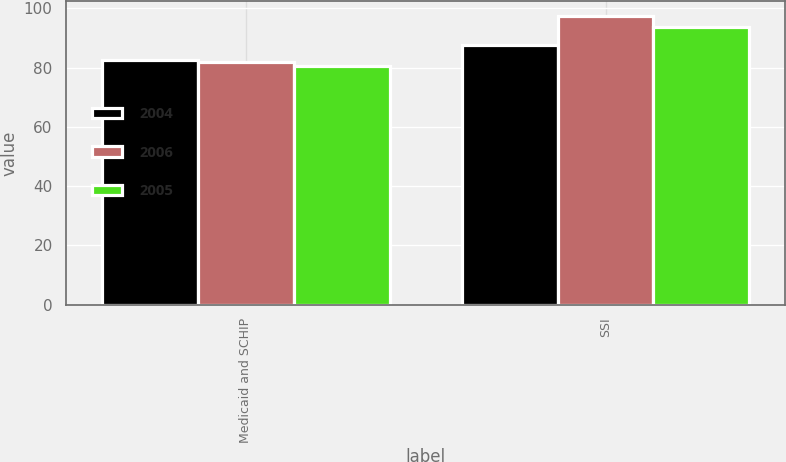Convert chart to OTSL. <chart><loc_0><loc_0><loc_500><loc_500><stacked_bar_chart><ecel><fcel>Medicaid and SCHIP<fcel>SSI<nl><fcel>2004<fcel>82.6<fcel>87.6<nl><fcel>2006<fcel>81.8<fcel>97.5<nl><fcel>2005<fcel>80.4<fcel>93.8<nl></chart> 